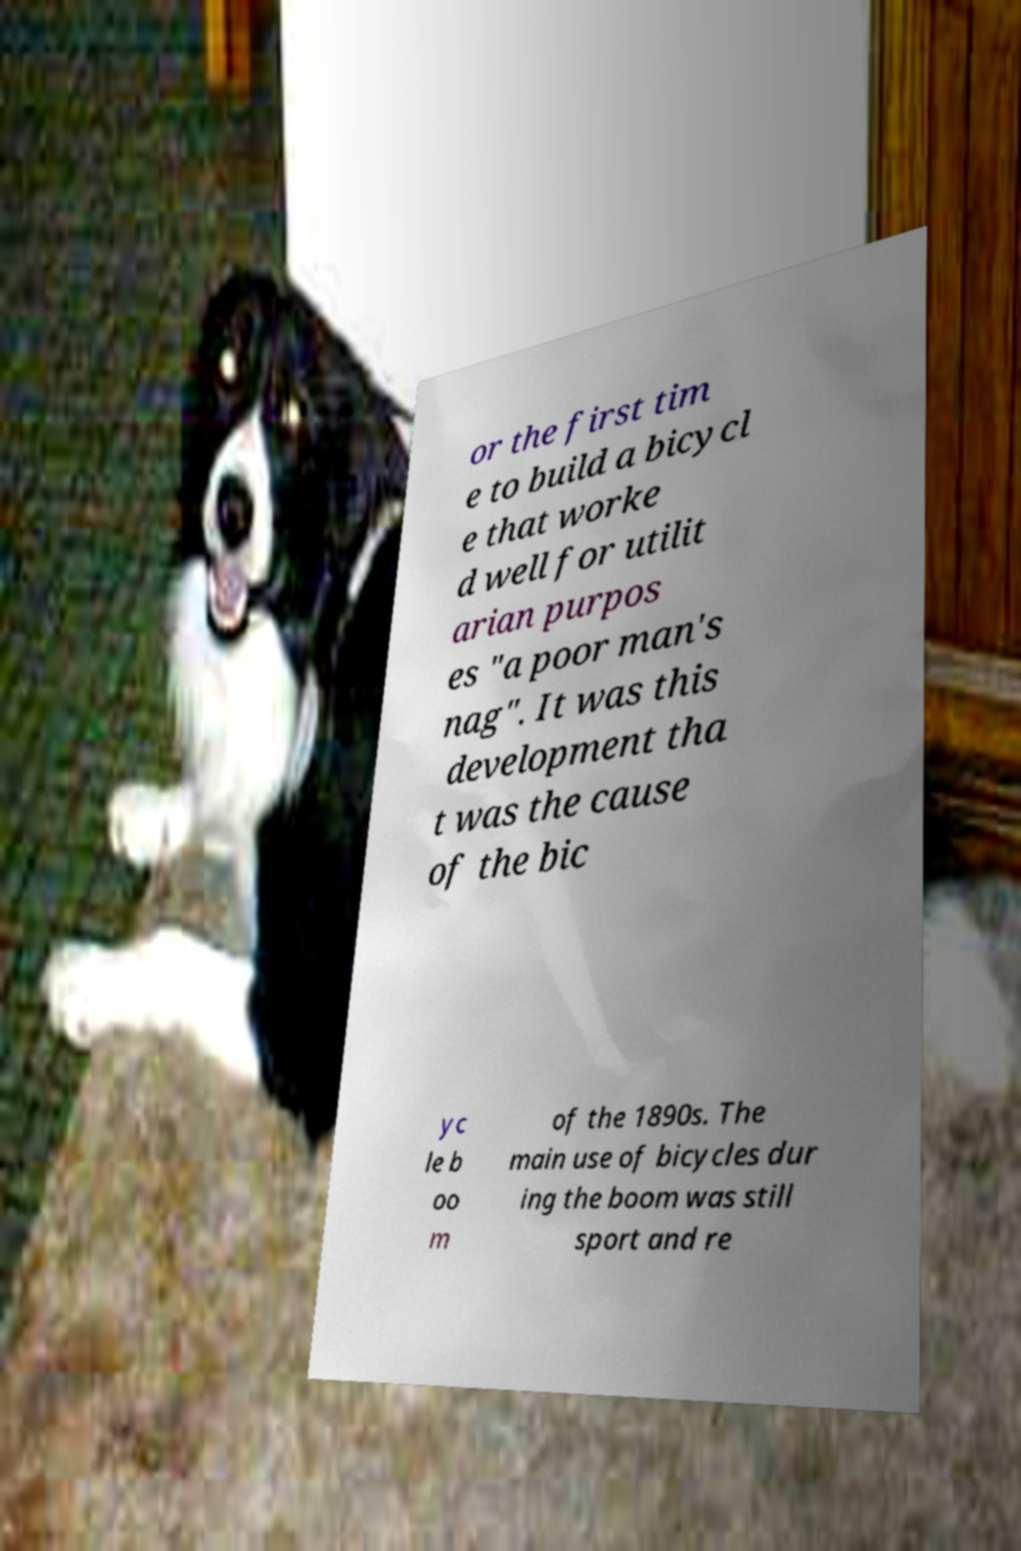Can you read and provide the text displayed in the image?This photo seems to have some interesting text. Can you extract and type it out for me? or the first tim e to build a bicycl e that worke d well for utilit arian purpos es "a poor man's nag". It was this development tha t was the cause of the bic yc le b oo m of the 1890s. The main use of bicycles dur ing the boom was still sport and re 